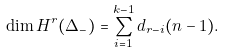Convert formula to latex. <formula><loc_0><loc_0><loc_500><loc_500>\dim H ^ { r } ( \Delta _ { - } ) = \sum _ { i = 1 } ^ { k - 1 } d _ { r - i } ( n - 1 ) .</formula> 